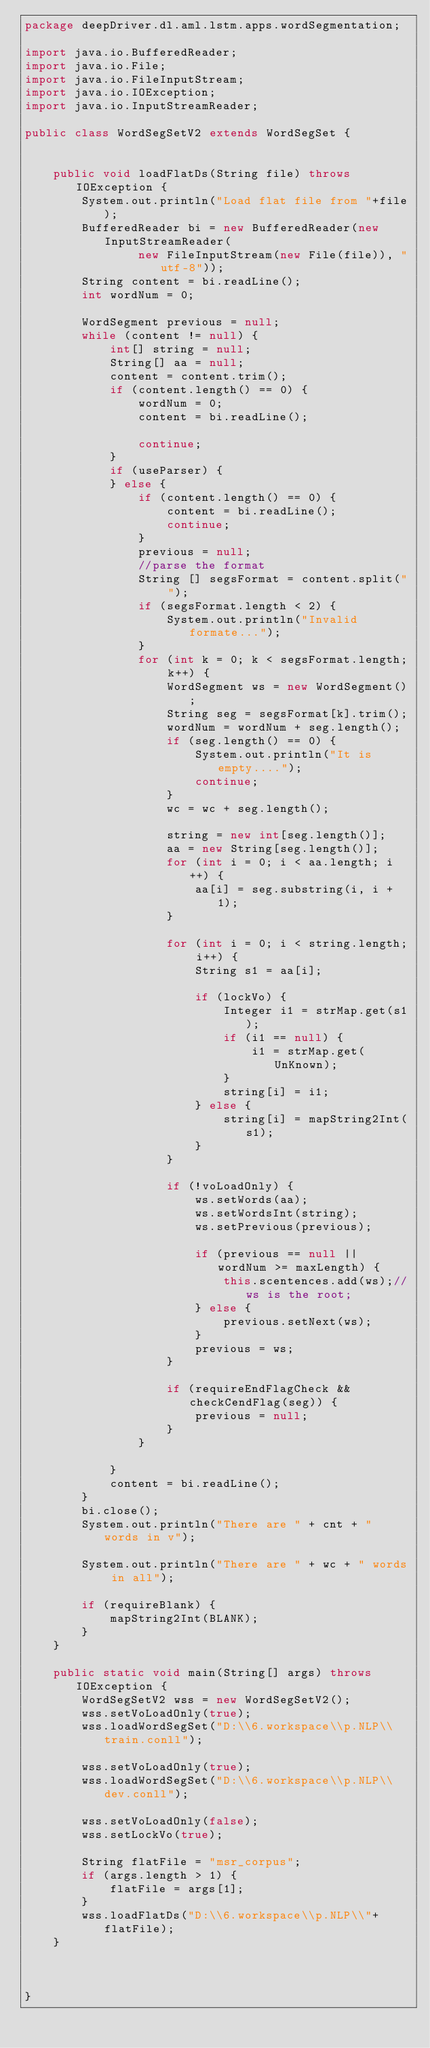<code> <loc_0><loc_0><loc_500><loc_500><_Java_>package deepDriver.dl.aml.lstm.apps.wordSegmentation;

import java.io.BufferedReader;
import java.io.File;
import java.io.FileInputStream;
import java.io.IOException;
import java.io.InputStreamReader;

public class WordSegSetV2 extends WordSegSet {
 
	
	public void loadFlatDs(String file) throws IOException {
		System.out.println("Load flat file from "+file);
		BufferedReader bi = new BufferedReader(new InputStreamReader(
				new FileInputStream(new File(file)), "utf-8"));
		String content = bi.readLine();
		int wordNum = 0;
		
		WordSegment previous = null;
		while (content != null) {
			int[] string = null;
			String[] aa = null;
			content = content.trim();
			if (content.length() == 0) {
				wordNum = 0;
				content = bi.readLine();				
				continue;
			} 
			if (useParser) { 
			} else {
				if (content.length() == 0) {
					content = bi.readLine();
					continue;
				} 
				previous = null;
				//parse the format
				String [] segsFormat = content.split(" ");
				if (segsFormat.length < 2) {
					System.out.println("Invalid formate...");
				}
				for (int k = 0; k < segsFormat.length; k++) {
					WordSegment ws = new WordSegment();
					String seg = segsFormat[k].trim();
					wordNum = wordNum + seg.length();
					if (seg.length() == 0) {
						System.out.println("It is empty....");
						continue;
					}
					wc = wc + seg.length();
				
					string = new int[seg.length()];
					aa = new String[seg.length()];
					for (int i = 0; i < aa.length; i++) {
						aa[i] = seg.substring(i, i + 1);
					}
					
					for (int i = 0; i < string.length; i++) {
						String s1 = aa[i];								
						if (lockVo) {
							Integer i1 = strMap.get(s1);
							if (i1 == null) {
								i1 = strMap.get(UnKnown);
							}
							string[i] = i1;
						} else {
							string[i] = mapString2Int(s1);
						}				
					}
					
					if (!voLoadOnly) {
						ws.setWords(aa);
						ws.setWordsInt(string);
						ws.setPrevious(previous);
					
						if (previous == null || wordNum >= maxLength) {
							this.scentences.add(ws);//ws is the root;
						} else {
							previous.setNext(ws);
						}
						previous = ws;
					}
					
					if (requireEndFlagCheck && checkCendFlag(seg)) {
						previous = null;
					}	 
				}
				 
			} 
			content = bi.readLine();
		}
		bi.close();
		System.out.println("There are " + cnt + " words in v");
		
		System.out.println("There are " + wc + " words in all");

		if (requireBlank) {			
			mapString2Int(BLANK);
		}
	}
	
	public static void main(String[] args) throws IOException {
		WordSegSetV2 wss = new WordSegSetV2();
		wss.setVoLoadOnly(true);		
		wss.loadWordSegSet("D:\\6.workspace\\p.NLP\\train.conll");
		 
		wss.setVoLoadOnly(true);
		wss.loadWordSegSet("D:\\6.workspace\\p.NLP\\dev.conll"); 
		
		wss.setVoLoadOnly(false);		
		wss.setLockVo(true);
		
		String flatFile = "msr_corpus";
		if (args.length > 1) {
			flatFile = args[1];
		}
		wss.loadFlatDs("D:\\6.workspace\\p.NLP\\"+flatFile); 
	}
	
	

}
</code> 